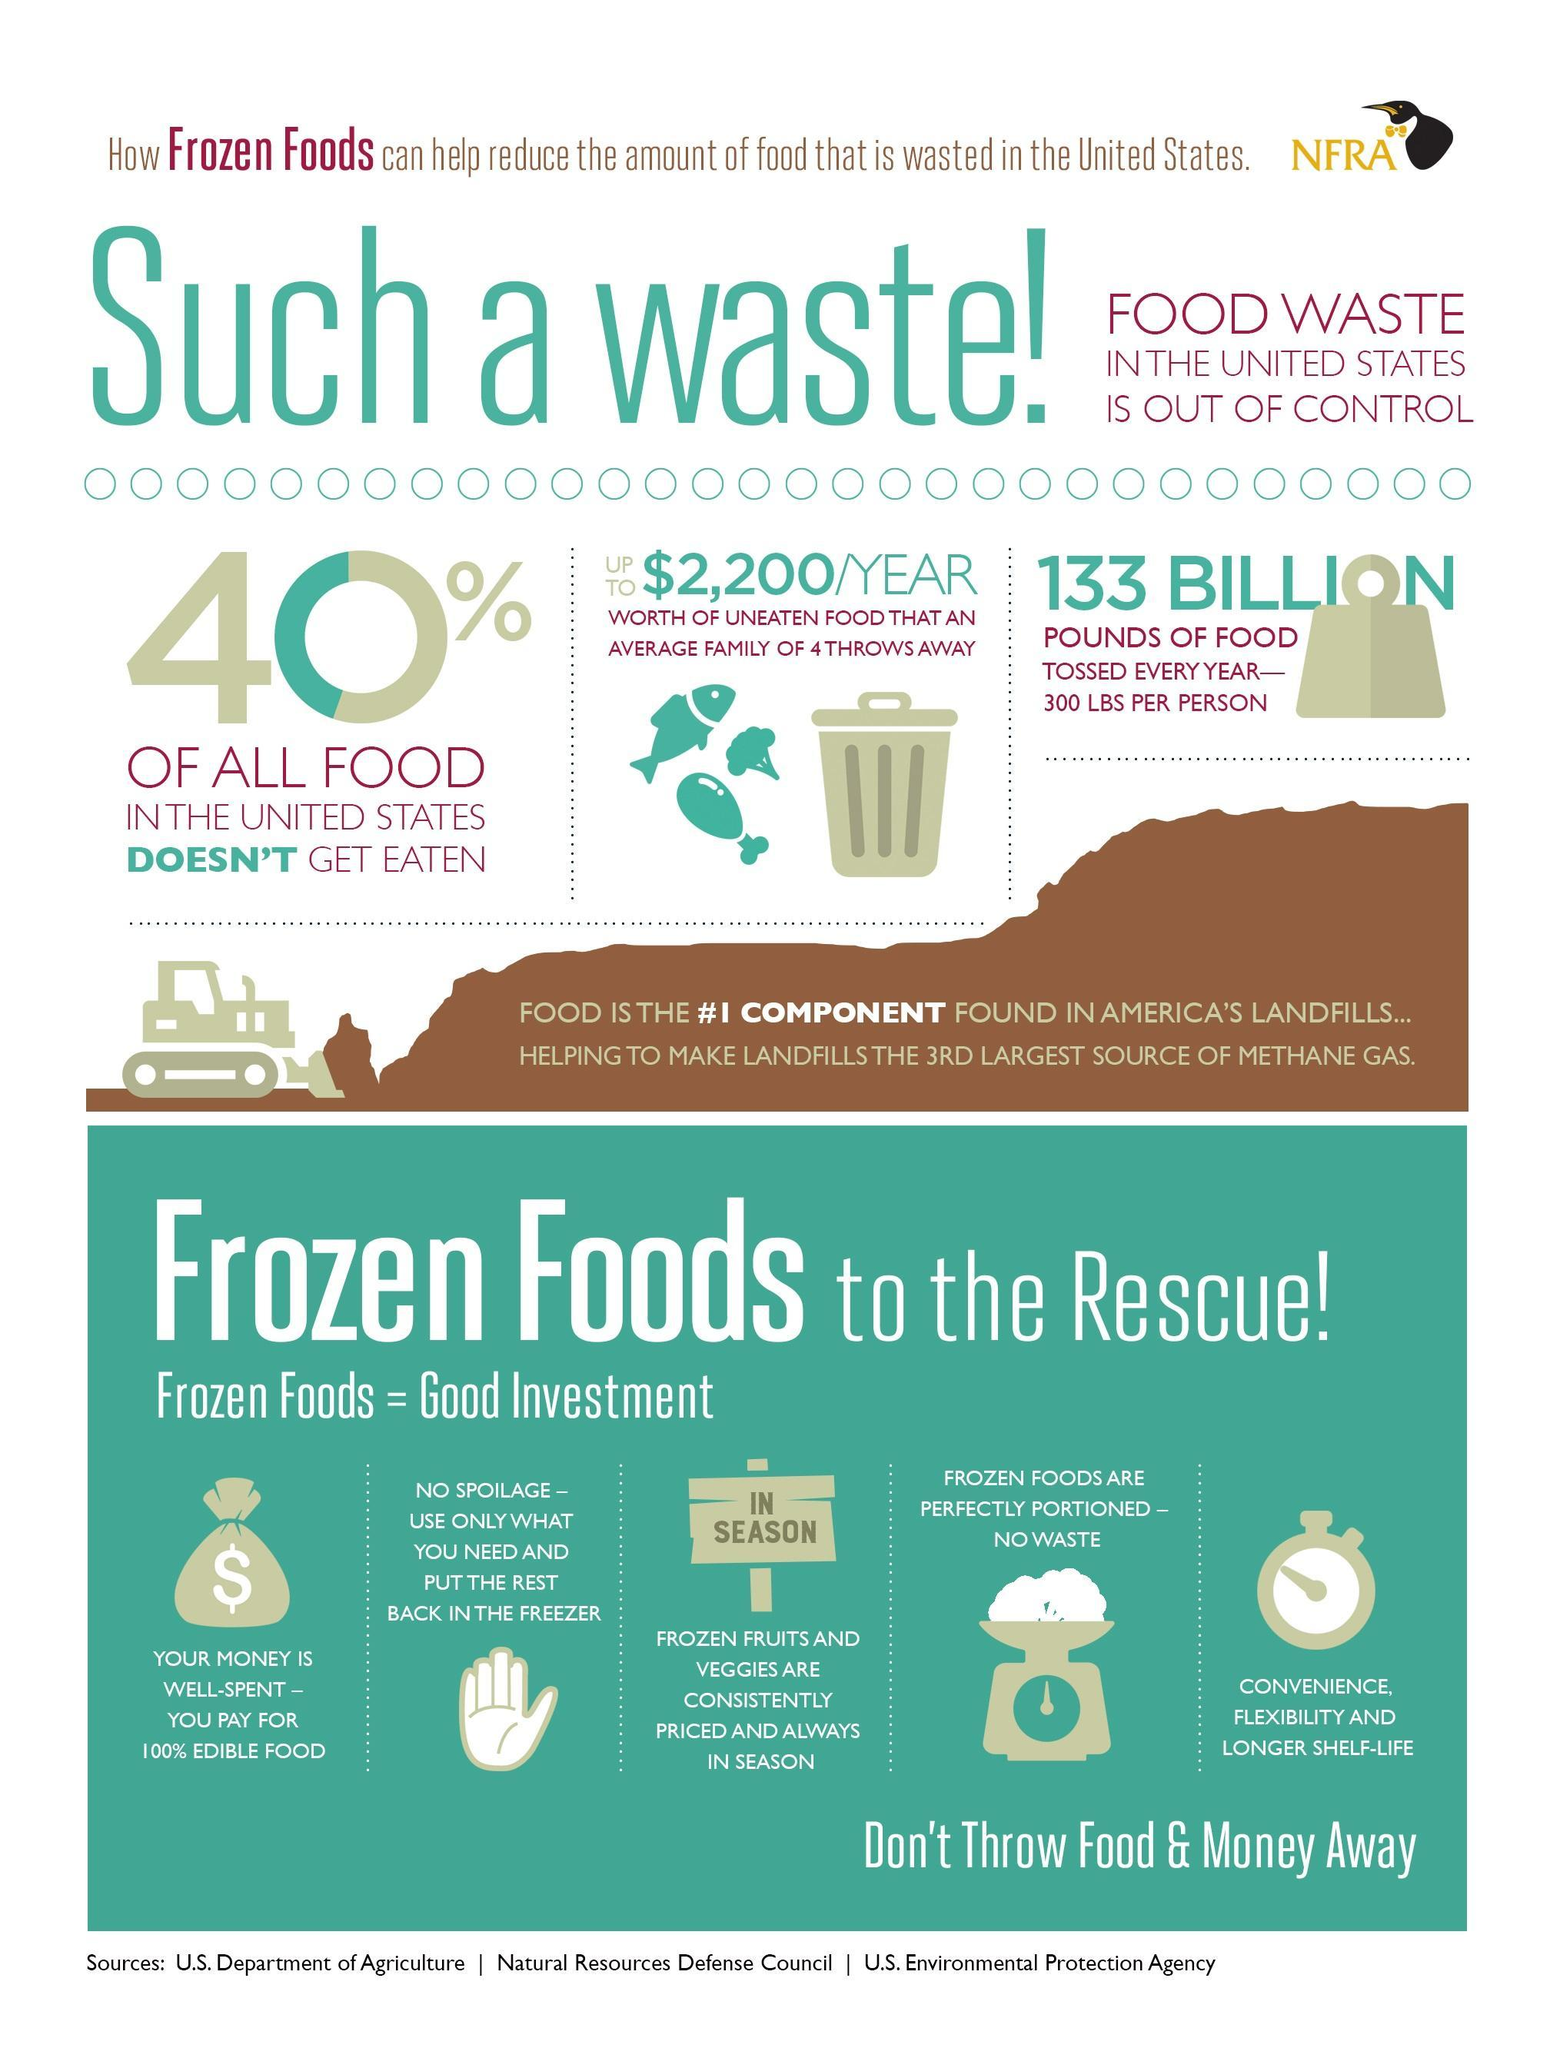Which food is always in season?
Answer the question with a short phrase. Frozen foods What is the total weight of the food wasted in US each year? 133 billion pounds Which food is perfectly portioned and so has no wastage? Frozen foods What is the currency shown on the image of the money bag - dollar, pound or rupee? Dollar Which foods have a longer shelf life? Frozen foods What is written on the image of the placard? In season How much worth of food is wasted by an average family of 4 in the US every year? $2,200 What is the fourth reason given for choosing frozen foods? Frozen foods are perfectly portioned - no waste How many reasons for buying Frozen food, are mentioned here? 5 What percent of food in the US doesn't get eaten? 40% 